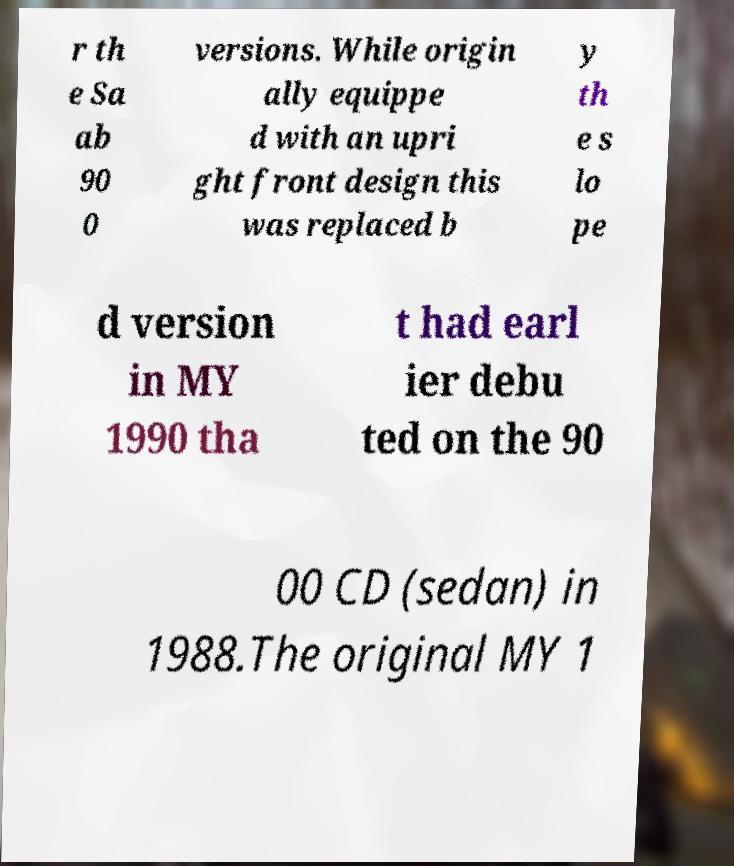Can you accurately transcribe the text from the provided image for me? r th e Sa ab 90 0 versions. While origin ally equippe d with an upri ght front design this was replaced b y th e s lo pe d version in MY 1990 tha t had earl ier debu ted on the 90 00 CD (sedan) in 1988.The original MY 1 